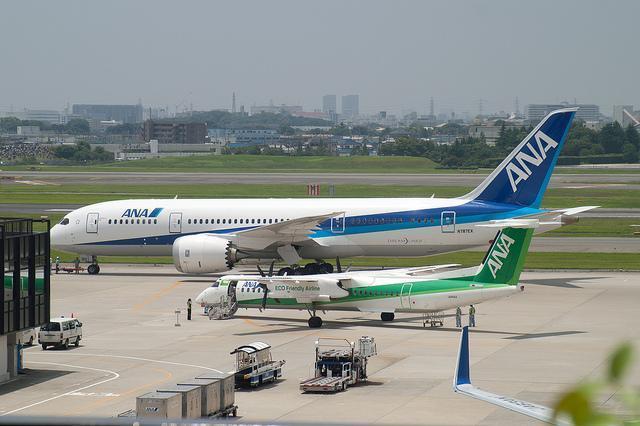How many planes are on the ground?
Give a very brief answer. 2. How many airplanes are in the photo?
Give a very brief answer. 2. How many train cars have some yellow on them?
Give a very brief answer. 0. 